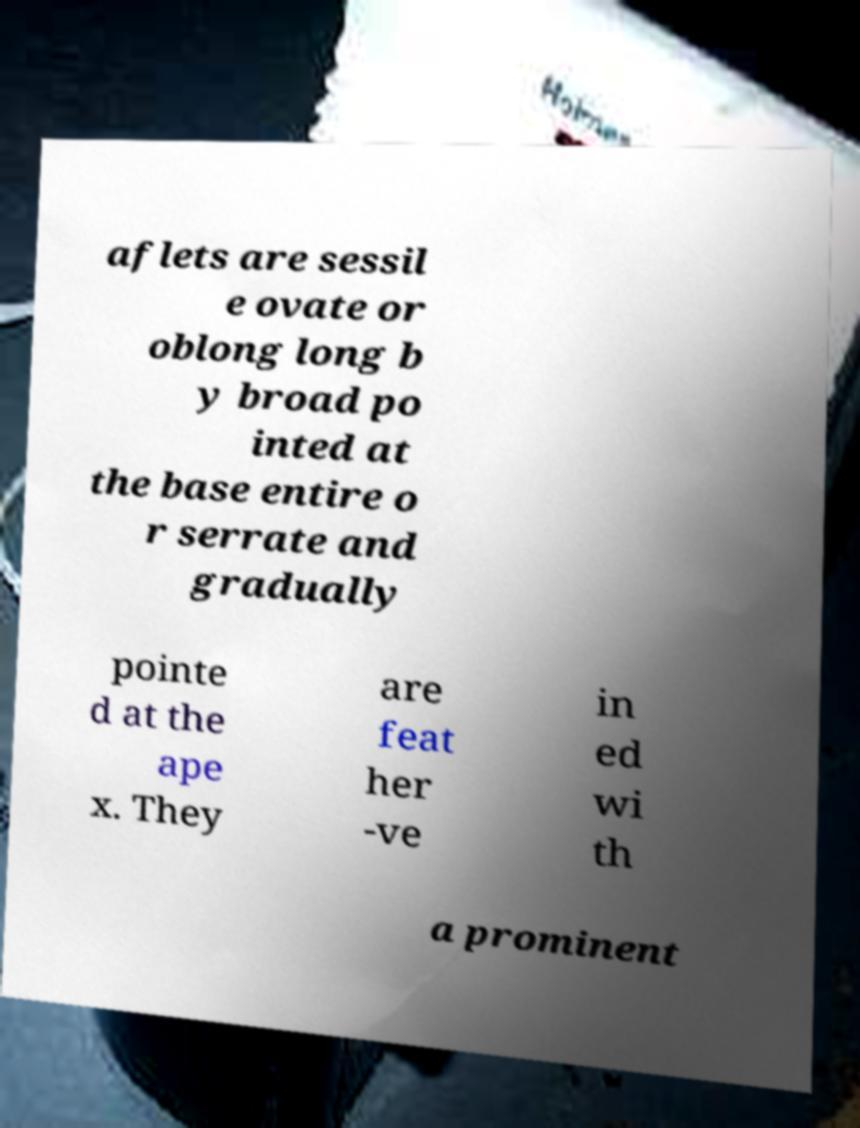Could you extract and type out the text from this image? aflets are sessil e ovate or oblong long b y broad po inted at the base entire o r serrate and gradually pointe d at the ape x. They are feat her -ve in ed wi th a prominent 